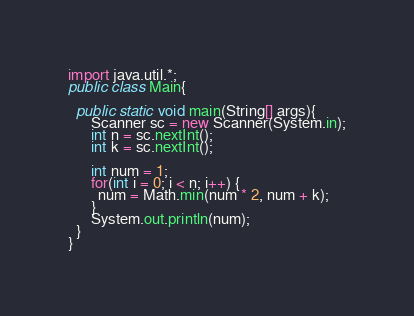<code> <loc_0><loc_0><loc_500><loc_500><_Java_>import java.util.*;
public class Main{

  public static void main(String[] args){
      Scanner sc = new Scanner(System.in);
      int n = sc.nextInt();
      int k = sc.nextInt();

      int num = 1;
      for(int i = 0; i < n; i++) {
        num = Math.min(num * 2, num + k);
      }
      System.out.println(num);
  }
}

</code> 